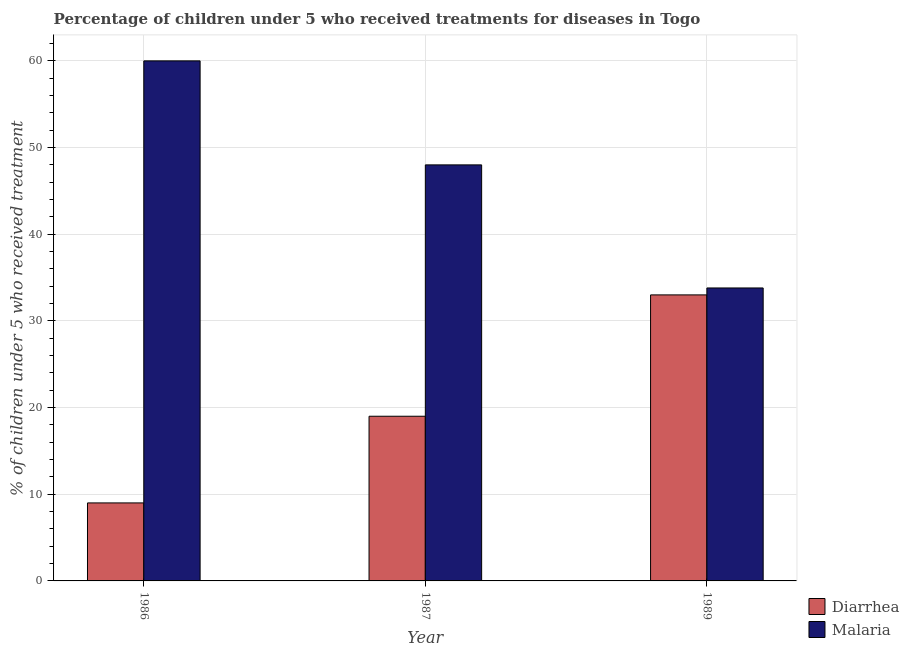What is the label of the 2nd group of bars from the left?
Offer a very short reply. 1987. In how many cases, is the number of bars for a given year not equal to the number of legend labels?
Your answer should be very brief. 0. What is the percentage of children who received treatment for diarrhoea in 1989?
Keep it short and to the point. 33. Across all years, what is the maximum percentage of children who received treatment for diarrhoea?
Make the answer very short. 33. Across all years, what is the minimum percentage of children who received treatment for diarrhoea?
Ensure brevity in your answer.  9. In which year was the percentage of children who received treatment for diarrhoea minimum?
Make the answer very short. 1986. What is the total percentage of children who received treatment for diarrhoea in the graph?
Make the answer very short. 61. What is the difference between the percentage of children who received treatment for diarrhoea in 1986 and that in 1987?
Give a very brief answer. -10. What is the average percentage of children who received treatment for diarrhoea per year?
Your answer should be compact. 20.33. Is the percentage of children who received treatment for diarrhoea in 1986 less than that in 1989?
Make the answer very short. Yes. What is the difference between the highest and the lowest percentage of children who received treatment for malaria?
Keep it short and to the point. 26.2. What does the 2nd bar from the left in 1986 represents?
Offer a very short reply. Malaria. What does the 2nd bar from the right in 1987 represents?
Offer a terse response. Diarrhea. How many bars are there?
Keep it short and to the point. 6. Are all the bars in the graph horizontal?
Provide a short and direct response. No. What is the difference between two consecutive major ticks on the Y-axis?
Provide a succinct answer. 10. Are the values on the major ticks of Y-axis written in scientific E-notation?
Ensure brevity in your answer.  No. Does the graph contain grids?
Your response must be concise. Yes. What is the title of the graph?
Provide a succinct answer. Percentage of children under 5 who received treatments for diseases in Togo. Does "Net National savings" appear as one of the legend labels in the graph?
Keep it short and to the point. No. What is the label or title of the X-axis?
Keep it short and to the point. Year. What is the label or title of the Y-axis?
Your response must be concise. % of children under 5 who received treatment. What is the % of children under 5 who received treatment in Diarrhea in 1986?
Your answer should be compact. 9. What is the % of children under 5 who received treatment of Diarrhea in 1987?
Provide a succinct answer. 19. What is the % of children under 5 who received treatment in Diarrhea in 1989?
Your response must be concise. 33. What is the % of children under 5 who received treatment of Malaria in 1989?
Offer a very short reply. 33.8. Across all years, what is the minimum % of children under 5 who received treatment of Malaria?
Provide a short and direct response. 33.8. What is the total % of children under 5 who received treatment in Diarrhea in the graph?
Your answer should be compact. 61. What is the total % of children under 5 who received treatment in Malaria in the graph?
Give a very brief answer. 141.8. What is the difference between the % of children under 5 who received treatment of Diarrhea in 1986 and that in 1987?
Ensure brevity in your answer.  -10. What is the difference between the % of children under 5 who received treatment of Diarrhea in 1986 and that in 1989?
Provide a succinct answer. -24. What is the difference between the % of children under 5 who received treatment in Malaria in 1986 and that in 1989?
Offer a terse response. 26.2. What is the difference between the % of children under 5 who received treatment in Malaria in 1987 and that in 1989?
Your answer should be compact. 14.2. What is the difference between the % of children under 5 who received treatment of Diarrhea in 1986 and the % of children under 5 who received treatment of Malaria in 1987?
Make the answer very short. -39. What is the difference between the % of children under 5 who received treatment in Diarrhea in 1986 and the % of children under 5 who received treatment in Malaria in 1989?
Offer a terse response. -24.8. What is the difference between the % of children under 5 who received treatment of Diarrhea in 1987 and the % of children under 5 who received treatment of Malaria in 1989?
Provide a succinct answer. -14.8. What is the average % of children under 5 who received treatment in Diarrhea per year?
Your response must be concise. 20.33. What is the average % of children under 5 who received treatment in Malaria per year?
Provide a short and direct response. 47.27. In the year 1986, what is the difference between the % of children under 5 who received treatment in Diarrhea and % of children under 5 who received treatment in Malaria?
Your response must be concise. -51. In the year 1987, what is the difference between the % of children under 5 who received treatment of Diarrhea and % of children under 5 who received treatment of Malaria?
Give a very brief answer. -29. What is the ratio of the % of children under 5 who received treatment in Diarrhea in 1986 to that in 1987?
Provide a succinct answer. 0.47. What is the ratio of the % of children under 5 who received treatment of Diarrhea in 1986 to that in 1989?
Your answer should be compact. 0.27. What is the ratio of the % of children under 5 who received treatment in Malaria in 1986 to that in 1989?
Provide a succinct answer. 1.78. What is the ratio of the % of children under 5 who received treatment in Diarrhea in 1987 to that in 1989?
Your answer should be very brief. 0.58. What is the ratio of the % of children under 5 who received treatment of Malaria in 1987 to that in 1989?
Make the answer very short. 1.42. What is the difference between the highest and the second highest % of children under 5 who received treatment in Diarrhea?
Your answer should be compact. 14. What is the difference between the highest and the lowest % of children under 5 who received treatment in Malaria?
Keep it short and to the point. 26.2. 